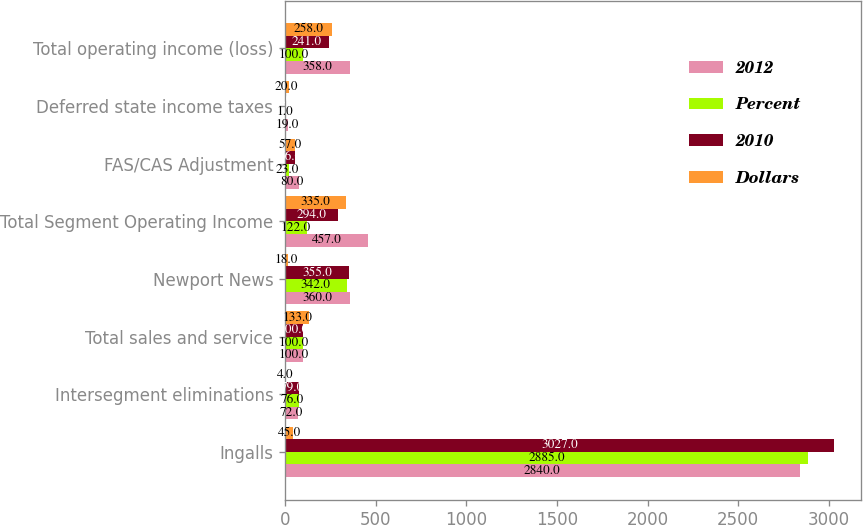Convert chart to OTSL. <chart><loc_0><loc_0><loc_500><loc_500><stacked_bar_chart><ecel><fcel>Ingalls<fcel>Intersegment eliminations<fcel>Total sales and service<fcel>Newport News<fcel>Total Segment Operating Income<fcel>FAS/CAS Adjustment<fcel>Deferred state income taxes<fcel>Total operating income (loss)<nl><fcel>2012<fcel>2840<fcel>72<fcel>100<fcel>360<fcel>457<fcel>80<fcel>19<fcel>358<nl><fcel>Percent<fcel>2885<fcel>76<fcel>100<fcel>342<fcel>122<fcel>23<fcel>1<fcel>100<nl><fcel>2010<fcel>3027<fcel>79<fcel>100<fcel>355<fcel>294<fcel>56<fcel>3<fcel>241<nl><fcel>Dollars<fcel>45<fcel>4<fcel>133<fcel>18<fcel>335<fcel>57<fcel>20<fcel>258<nl></chart> 